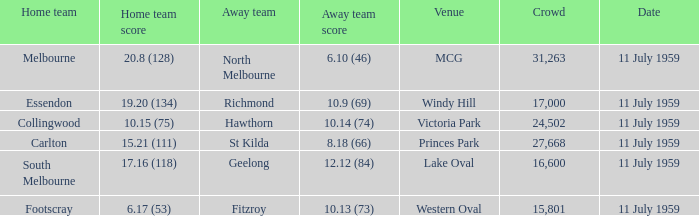How many points does footscray score as the home side? 6.17 (53). 